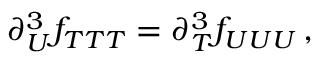Convert formula to latex. <formula><loc_0><loc_0><loc_500><loc_500>\partial _ { U } ^ { 3 } f _ { T T T } = \partial _ { T } ^ { 3 } f _ { U U U } \, ,</formula> 